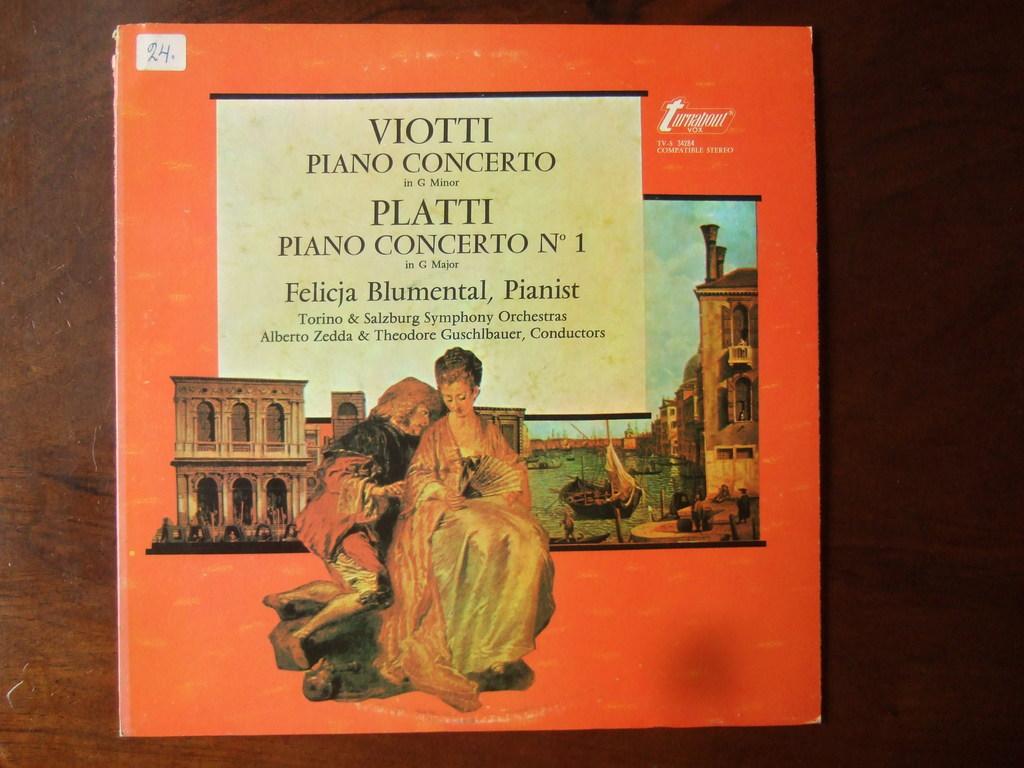What instrument does blumental play?
Your answer should be very brief. Piano. Which artist's piano concerto is featured?
Give a very brief answer. Viotti. 